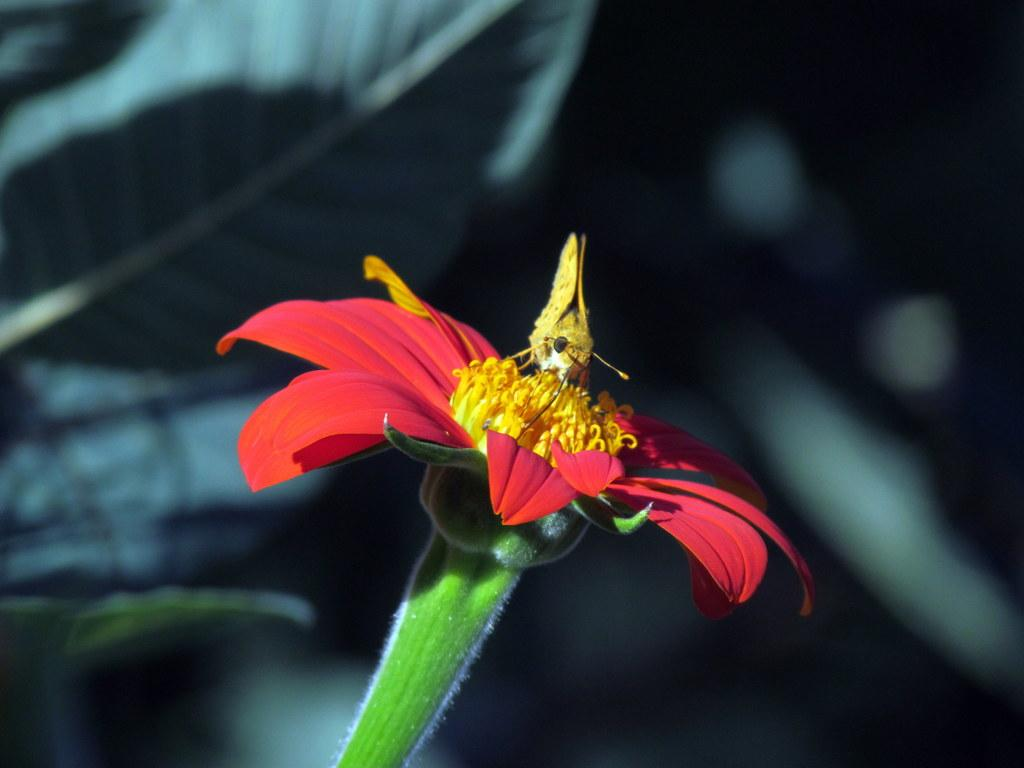What color is the flower in the image? The flower in the image is red. What can be seen on the flower besides its petals? The flower has yellow filaments. Is there any other living organism present on the flower? Yes, there is an insect on the filaments. How would you describe the background of the image? The background of the image is blurred. What type of jellyfish can be seen swimming in the background of the image? There is no jellyfish present in the image; it features a red flower with yellow filaments and an insect. 